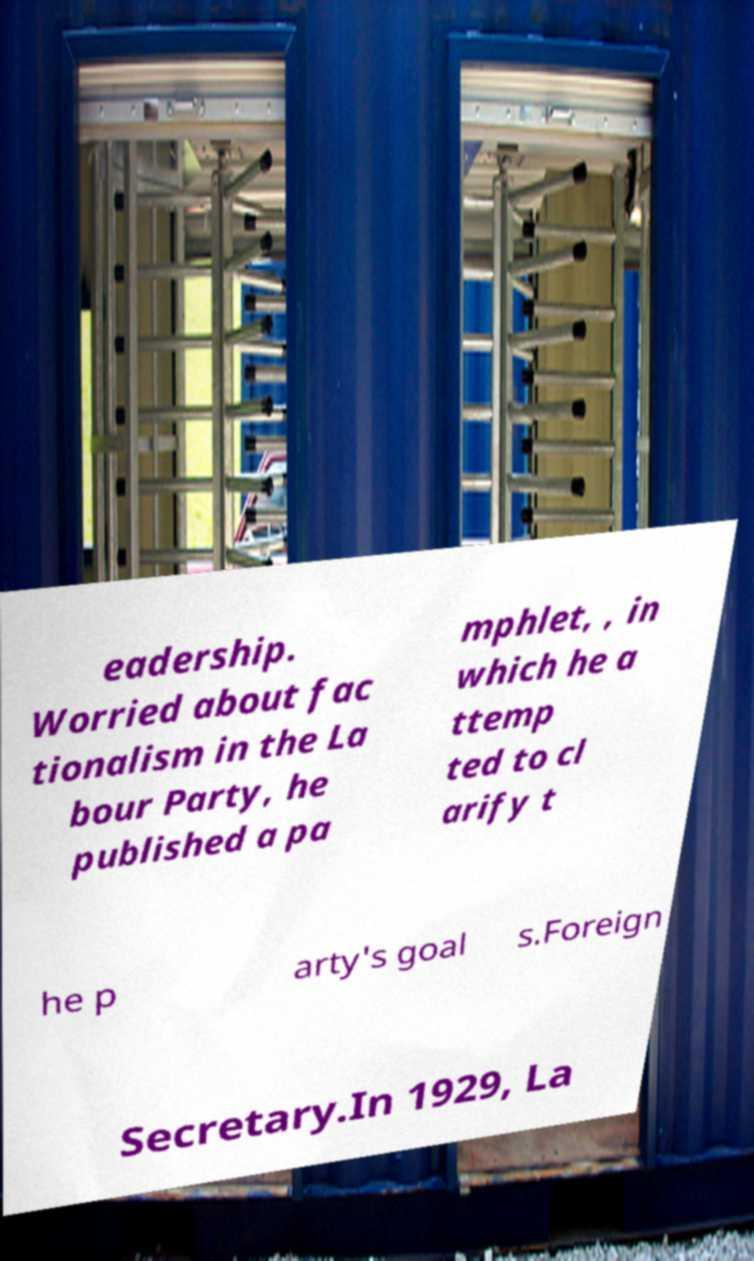For documentation purposes, I need the text within this image transcribed. Could you provide that? eadership. Worried about fac tionalism in the La bour Party, he published a pa mphlet, , in which he a ttemp ted to cl arify t he p arty's goal s.Foreign Secretary.In 1929, La 